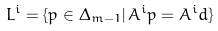Convert formula to latex. <formula><loc_0><loc_0><loc_500><loc_500>L ^ { i } = \{ p \in \Delta _ { m - 1 } | \, A ^ { i } p = A ^ { i } d \}</formula> 